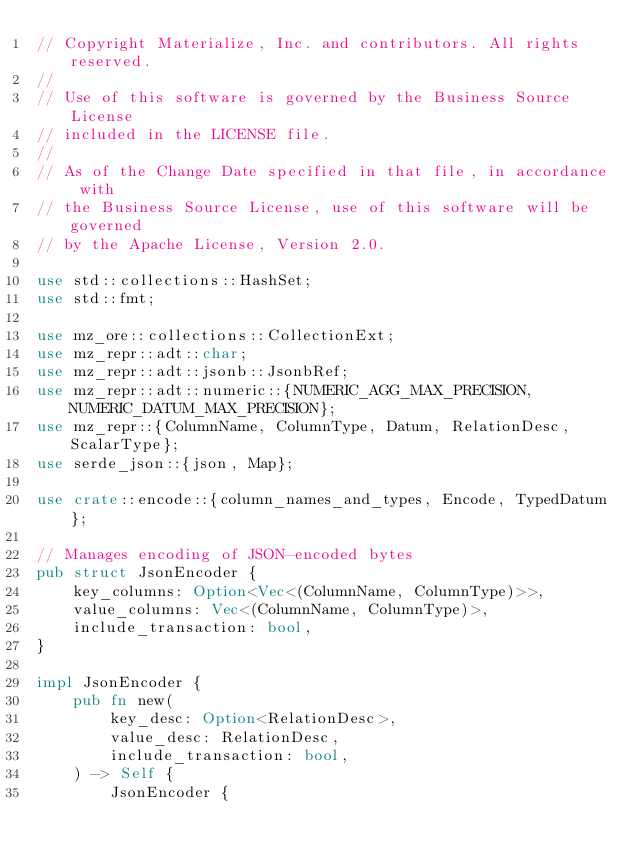Convert code to text. <code><loc_0><loc_0><loc_500><loc_500><_Rust_>// Copyright Materialize, Inc. and contributors. All rights reserved.
//
// Use of this software is governed by the Business Source License
// included in the LICENSE file.
//
// As of the Change Date specified in that file, in accordance with
// the Business Source License, use of this software will be governed
// by the Apache License, Version 2.0.

use std::collections::HashSet;
use std::fmt;

use mz_ore::collections::CollectionExt;
use mz_repr::adt::char;
use mz_repr::adt::jsonb::JsonbRef;
use mz_repr::adt::numeric::{NUMERIC_AGG_MAX_PRECISION, NUMERIC_DATUM_MAX_PRECISION};
use mz_repr::{ColumnName, ColumnType, Datum, RelationDesc, ScalarType};
use serde_json::{json, Map};

use crate::encode::{column_names_and_types, Encode, TypedDatum};

// Manages encoding of JSON-encoded bytes
pub struct JsonEncoder {
    key_columns: Option<Vec<(ColumnName, ColumnType)>>,
    value_columns: Vec<(ColumnName, ColumnType)>,
    include_transaction: bool,
}

impl JsonEncoder {
    pub fn new(
        key_desc: Option<RelationDesc>,
        value_desc: RelationDesc,
        include_transaction: bool,
    ) -> Self {
        JsonEncoder {</code> 